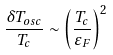<formula> <loc_0><loc_0><loc_500><loc_500>\frac { \delta T _ { o s c } } { T _ { c } } \sim \left ( \frac { T _ { c } } { \varepsilon _ { F } } \right ) ^ { 2 }</formula> 